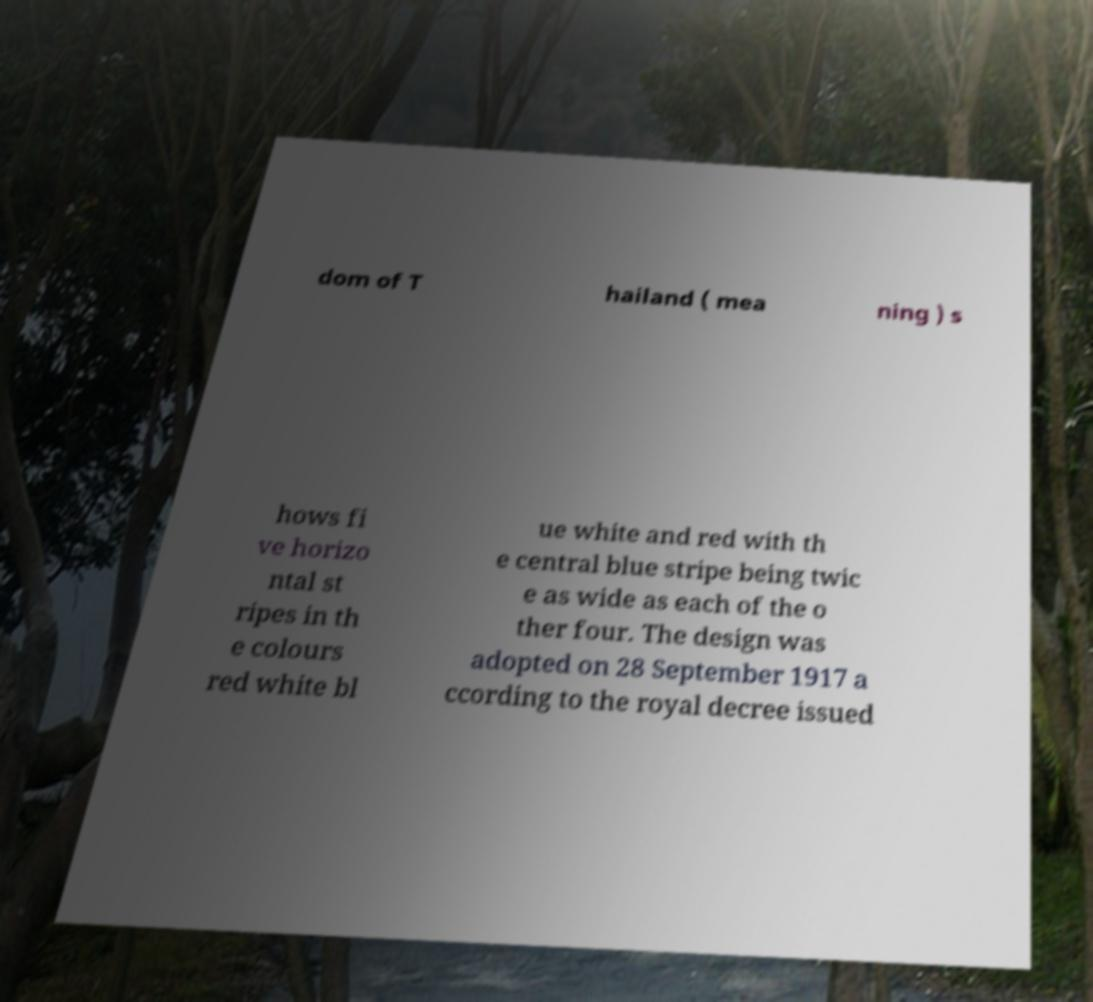What messages or text are displayed in this image? I need them in a readable, typed format. dom of T hailand ( mea ning ) s hows fi ve horizo ntal st ripes in th e colours red white bl ue white and red with th e central blue stripe being twic e as wide as each of the o ther four. The design was adopted on 28 September 1917 a ccording to the royal decree issued 